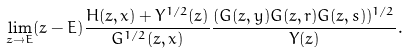<formula> <loc_0><loc_0><loc_500><loc_500>\lim _ { z \to E } ( z - E ) \frac { H ( z , x ) + Y ^ { 1 / 2 } ( z ) } { G ^ { 1 / 2 } ( z , x ) } \frac { ( G ( z , y ) G ( z , r ) G ( z , s ) ) ^ { 1 / 2 } } { Y ( z ) } .</formula> 